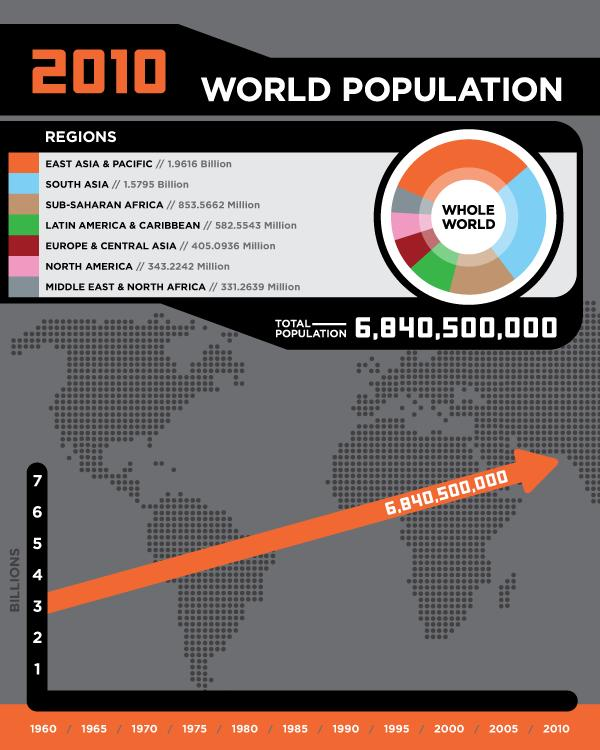Give some essential details in this illustration. The total population of Central Asia, South Asia, and Europe taken together is approximately 1.9 billion. The Middle East and North Africa region has the smallest population among the given regions. The region with the fourth largest population is Latin America & Caribbean. The total population of East Asia and Pacific, South Asia, and Sub-Saharan Africa combined is approximately 4.39 billion. According to the given value, the total population of Sub-Saharan Africa and the Middle East and North Africa regions taken together is 1184.8301 million. 